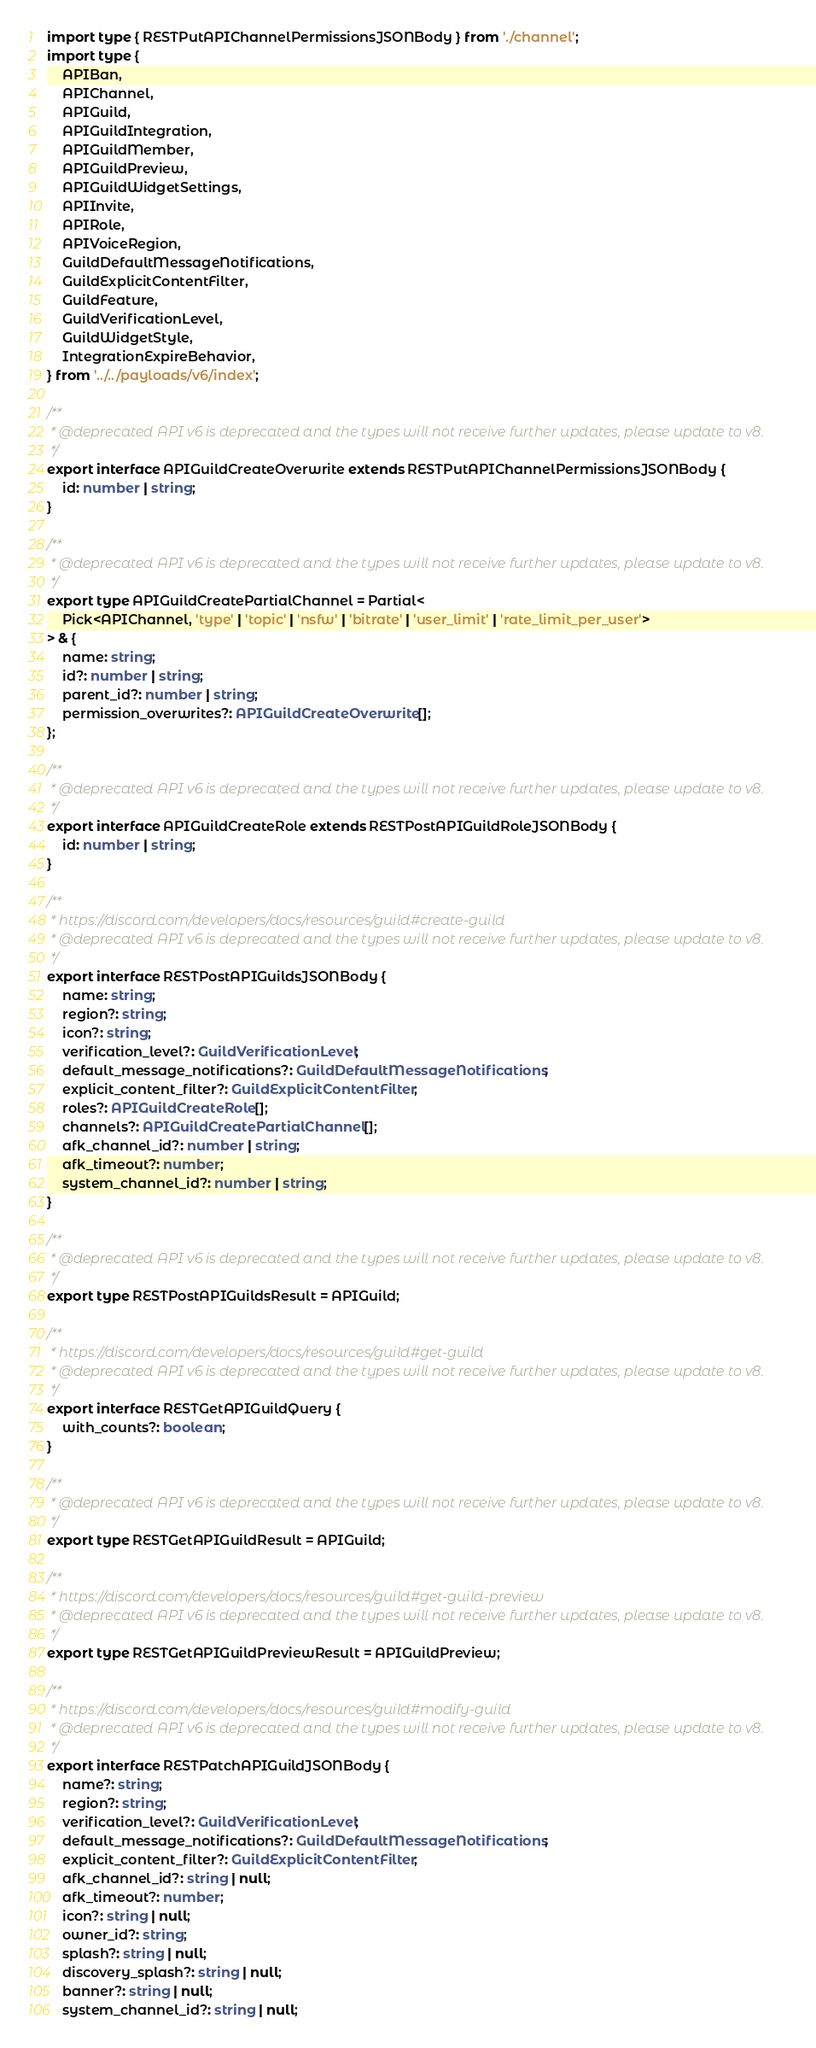Convert code to text. <code><loc_0><loc_0><loc_500><loc_500><_TypeScript_>import type { RESTPutAPIChannelPermissionsJSONBody } from './channel';
import type {
	APIBan,
	APIChannel,
	APIGuild,
	APIGuildIntegration,
	APIGuildMember,
	APIGuildPreview,
	APIGuildWidgetSettings,
	APIInvite,
	APIRole,
	APIVoiceRegion,
	GuildDefaultMessageNotifications,
	GuildExplicitContentFilter,
	GuildFeature,
	GuildVerificationLevel,
	GuildWidgetStyle,
	IntegrationExpireBehavior,
} from '../../payloads/v6/index';

/**
 * @deprecated API v6 is deprecated and the types will not receive further updates, please update to v8.
 */
export interface APIGuildCreateOverwrite extends RESTPutAPIChannelPermissionsJSONBody {
	id: number | string;
}

/**
 * @deprecated API v6 is deprecated and the types will not receive further updates, please update to v8.
 */
export type APIGuildCreatePartialChannel = Partial<
	Pick<APIChannel, 'type' | 'topic' | 'nsfw' | 'bitrate' | 'user_limit' | 'rate_limit_per_user'>
> & {
	name: string;
	id?: number | string;
	parent_id?: number | string;
	permission_overwrites?: APIGuildCreateOverwrite[];
};

/**
 * @deprecated API v6 is deprecated and the types will not receive further updates, please update to v8.
 */
export interface APIGuildCreateRole extends RESTPostAPIGuildRoleJSONBody {
	id: number | string;
}

/**
 * https://discord.com/developers/docs/resources/guild#create-guild
 * @deprecated API v6 is deprecated and the types will not receive further updates, please update to v8.
 */
export interface RESTPostAPIGuildsJSONBody {
	name: string;
	region?: string;
	icon?: string;
	verification_level?: GuildVerificationLevel;
	default_message_notifications?: GuildDefaultMessageNotifications;
	explicit_content_filter?: GuildExplicitContentFilter;
	roles?: APIGuildCreateRole[];
	channels?: APIGuildCreatePartialChannel[];
	afk_channel_id?: number | string;
	afk_timeout?: number;
	system_channel_id?: number | string;
}

/**
 * @deprecated API v6 is deprecated and the types will not receive further updates, please update to v8.
 */
export type RESTPostAPIGuildsResult = APIGuild;

/**
 * https://discord.com/developers/docs/resources/guild#get-guild
 * @deprecated API v6 is deprecated and the types will not receive further updates, please update to v8.
 */
export interface RESTGetAPIGuildQuery {
	with_counts?: boolean;
}

/**
 * @deprecated API v6 is deprecated and the types will not receive further updates, please update to v8.
 */
export type RESTGetAPIGuildResult = APIGuild;

/**
 * https://discord.com/developers/docs/resources/guild#get-guild-preview
 * @deprecated API v6 is deprecated and the types will not receive further updates, please update to v8.
 */
export type RESTGetAPIGuildPreviewResult = APIGuildPreview;

/**
 * https://discord.com/developers/docs/resources/guild#modify-guild
 * @deprecated API v6 is deprecated and the types will not receive further updates, please update to v8.
 */
export interface RESTPatchAPIGuildJSONBody {
	name?: string;
	region?: string;
	verification_level?: GuildVerificationLevel;
	default_message_notifications?: GuildDefaultMessageNotifications;
	explicit_content_filter?: GuildExplicitContentFilter;
	afk_channel_id?: string | null;
	afk_timeout?: number;
	icon?: string | null;
	owner_id?: string;
	splash?: string | null;
	discovery_splash?: string | null;
	banner?: string | null;
	system_channel_id?: string | null;</code> 